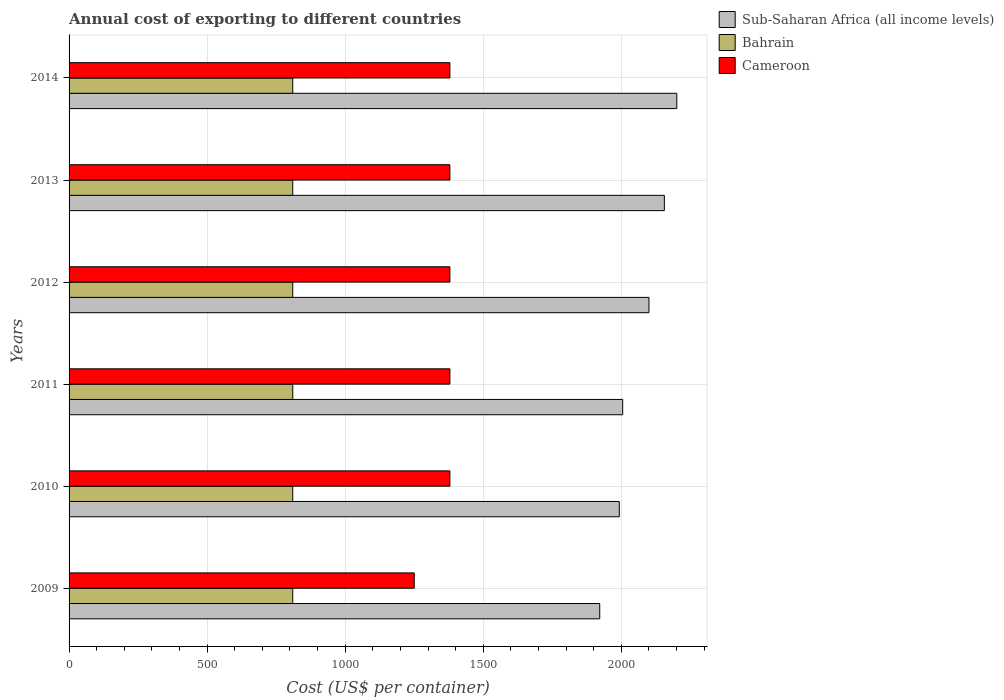How many different coloured bars are there?
Your answer should be very brief. 3. How many groups of bars are there?
Make the answer very short. 6. Are the number of bars per tick equal to the number of legend labels?
Keep it short and to the point. Yes. What is the total annual cost of exporting in Bahrain in 2010?
Offer a terse response. 810. Across all years, what is the maximum total annual cost of exporting in Bahrain?
Offer a terse response. 810. Across all years, what is the minimum total annual cost of exporting in Bahrain?
Provide a succinct answer. 810. In which year was the total annual cost of exporting in Bahrain minimum?
Offer a very short reply. 2009. What is the total total annual cost of exporting in Sub-Saharan Africa (all income levels) in the graph?
Keep it short and to the point. 1.24e+04. What is the difference between the total annual cost of exporting in Bahrain in 2009 and that in 2012?
Your answer should be very brief. 0. What is the difference between the total annual cost of exporting in Cameroon in 2011 and the total annual cost of exporting in Sub-Saharan Africa (all income levels) in 2013?
Offer a very short reply. -776.7. What is the average total annual cost of exporting in Bahrain per year?
Your response must be concise. 810. In the year 2009, what is the difference between the total annual cost of exporting in Sub-Saharan Africa (all income levels) and total annual cost of exporting in Cameroon?
Give a very brief answer. 671.63. What is the ratio of the total annual cost of exporting in Cameroon in 2009 to that in 2013?
Keep it short and to the point. 0.91. What is the difference between the highest and the second highest total annual cost of exporting in Bahrain?
Your answer should be very brief. 0. What is the difference between the highest and the lowest total annual cost of exporting in Cameroon?
Your answer should be compact. 129. In how many years, is the total annual cost of exporting in Cameroon greater than the average total annual cost of exporting in Cameroon taken over all years?
Ensure brevity in your answer.  5. What does the 2nd bar from the top in 2014 represents?
Provide a short and direct response. Bahrain. What does the 2nd bar from the bottom in 2010 represents?
Offer a very short reply. Bahrain. Is it the case that in every year, the sum of the total annual cost of exporting in Sub-Saharan Africa (all income levels) and total annual cost of exporting in Cameroon is greater than the total annual cost of exporting in Bahrain?
Give a very brief answer. Yes. How many bars are there?
Ensure brevity in your answer.  18. Are all the bars in the graph horizontal?
Provide a succinct answer. Yes. How many years are there in the graph?
Your response must be concise. 6. Are the values on the major ticks of X-axis written in scientific E-notation?
Offer a very short reply. No. Does the graph contain any zero values?
Your response must be concise. No. Where does the legend appear in the graph?
Your answer should be very brief. Top right. How are the legend labels stacked?
Offer a very short reply. Vertical. What is the title of the graph?
Give a very brief answer. Annual cost of exporting to different countries. Does "Congo (Democratic)" appear as one of the legend labels in the graph?
Your response must be concise. No. What is the label or title of the X-axis?
Keep it short and to the point. Cost (US$ per container). What is the Cost (US$ per container) in Sub-Saharan Africa (all income levels) in 2009?
Your answer should be compact. 1921.63. What is the Cost (US$ per container) in Bahrain in 2009?
Give a very brief answer. 810. What is the Cost (US$ per container) in Cameroon in 2009?
Your answer should be compact. 1250. What is the Cost (US$ per container) in Sub-Saharan Africa (all income levels) in 2010?
Make the answer very short. 1992.41. What is the Cost (US$ per container) of Bahrain in 2010?
Provide a succinct answer. 810. What is the Cost (US$ per container) of Cameroon in 2010?
Keep it short and to the point. 1379. What is the Cost (US$ per container) of Sub-Saharan Africa (all income levels) in 2011?
Keep it short and to the point. 2004.76. What is the Cost (US$ per container) of Bahrain in 2011?
Your answer should be very brief. 810. What is the Cost (US$ per container) of Cameroon in 2011?
Make the answer very short. 1379. What is the Cost (US$ per container) in Sub-Saharan Africa (all income levels) in 2012?
Provide a short and direct response. 2099.96. What is the Cost (US$ per container) of Bahrain in 2012?
Keep it short and to the point. 810. What is the Cost (US$ per container) of Cameroon in 2012?
Give a very brief answer. 1379. What is the Cost (US$ per container) of Sub-Saharan Africa (all income levels) in 2013?
Ensure brevity in your answer.  2155.7. What is the Cost (US$ per container) in Bahrain in 2013?
Your answer should be very brief. 810. What is the Cost (US$ per container) of Cameroon in 2013?
Offer a terse response. 1379. What is the Cost (US$ per container) in Sub-Saharan Africa (all income levels) in 2014?
Offer a very short reply. 2200.7. What is the Cost (US$ per container) of Bahrain in 2014?
Keep it short and to the point. 810. What is the Cost (US$ per container) of Cameroon in 2014?
Offer a terse response. 1379. Across all years, what is the maximum Cost (US$ per container) of Sub-Saharan Africa (all income levels)?
Offer a terse response. 2200.7. Across all years, what is the maximum Cost (US$ per container) in Bahrain?
Offer a terse response. 810. Across all years, what is the maximum Cost (US$ per container) of Cameroon?
Offer a very short reply. 1379. Across all years, what is the minimum Cost (US$ per container) of Sub-Saharan Africa (all income levels)?
Offer a terse response. 1921.63. Across all years, what is the minimum Cost (US$ per container) of Bahrain?
Provide a short and direct response. 810. Across all years, what is the minimum Cost (US$ per container) in Cameroon?
Your answer should be compact. 1250. What is the total Cost (US$ per container) in Sub-Saharan Africa (all income levels) in the graph?
Your answer should be very brief. 1.24e+04. What is the total Cost (US$ per container) of Bahrain in the graph?
Offer a very short reply. 4860. What is the total Cost (US$ per container) of Cameroon in the graph?
Offer a terse response. 8145. What is the difference between the Cost (US$ per container) of Sub-Saharan Africa (all income levels) in 2009 and that in 2010?
Provide a short and direct response. -70.78. What is the difference between the Cost (US$ per container) in Cameroon in 2009 and that in 2010?
Your answer should be very brief. -129. What is the difference between the Cost (US$ per container) in Sub-Saharan Africa (all income levels) in 2009 and that in 2011?
Offer a very short reply. -83.13. What is the difference between the Cost (US$ per container) in Bahrain in 2009 and that in 2011?
Provide a succinct answer. 0. What is the difference between the Cost (US$ per container) of Cameroon in 2009 and that in 2011?
Offer a very short reply. -129. What is the difference between the Cost (US$ per container) in Sub-Saharan Africa (all income levels) in 2009 and that in 2012?
Your answer should be compact. -178.33. What is the difference between the Cost (US$ per container) of Bahrain in 2009 and that in 2012?
Make the answer very short. 0. What is the difference between the Cost (US$ per container) of Cameroon in 2009 and that in 2012?
Provide a short and direct response. -129. What is the difference between the Cost (US$ per container) in Sub-Saharan Africa (all income levels) in 2009 and that in 2013?
Ensure brevity in your answer.  -234.07. What is the difference between the Cost (US$ per container) in Cameroon in 2009 and that in 2013?
Your response must be concise. -129. What is the difference between the Cost (US$ per container) in Sub-Saharan Africa (all income levels) in 2009 and that in 2014?
Your answer should be compact. -279.07. What is the difference between the Cost (US$ per container) of Cameroon in 2009 and that in 2014?
Give a very brief answer. -129. What is the difference between the Cost (US$ per container) in Sub-Saharan Africa (all income levels) in 2010 and that in 2011?
Provide a succinct answer. -12.35. What is the difference between the Cost (US$ per container) of Bahrain in 2010 and that in 2011?
Your answer should be very brief. 0. What is the difference between the Cost (US$ per container) in Sub-Saharan Africa (all income levels) in 2010 and that in 2012?
Your answer should be compact. -107.54. What is the difference between the Cost (US$ per container) in Sub-Saharan Africa (all income levels) in 2010 and that in 2013?
Make the answer very short. -163.29. What is the difference between the Cost (US$ per container) in Bahrain in 2010 and that in 2013?
Provide a short and direct response. 0. What is the difference between the Cost (US$ per container) in Sub-Saharan Africa (all income levels) in 2010 and that in 2014?
Make the answer very short. -208.29. What is the difference between the Cost (US$ per container) of Cameroon in 2010 and that in 2014?
Offer a terse response. 0. What is the difference between the Cost (US$ per container) of Sub-Saharan Africa (all income levels) in 2011 and that in 2012?
Make the answer very short. -95.2. What is the difference between the Cost (US$ per container) in Sub-Saharan Africa (all income levels) in 2011 and that in 2013?
Your response must be concise. -150.94. What is the difference between the Cost (US$ per container) of Bahrain in 2011 and that in 2013?
Provide a succinct answer. 0. What is the difference between the Cost (US$ per container) in Cameroon in 2011 and that in 2013?
Give a very brief answer. 0. What is the difference between the Cost (US$ per container) of Sub-Saharan Africa (all income levels) in 2011 and that in 2014?
Your answer should be very brief. -195.94. What is the difference between the Cost (US$ per container) of Sub-Saharan Africa (all income levels) in 2012 and that in 2013?
Provide a short and direct response. -55.74. What is the difference between the Cost (US$ per container) of Sub-Saharan Africa (all income levels) in 2012 and that in 2014?
Offer a terse response. -100.74. What is the difference between the Cost (US$ per container) of Sub-Saharan Africa (all income levels) in 2013 and that in 2014?
Provide a succinct answer. -45. What is the difference between the Cost (US$ per container) in Bahrain in 2013 and that in 2014?
Provide a succinct answer. 0. What is the difference between the Cost (US$ per container) of Sub-Saharan Africa (all income levels) in 2009 and the Cost (US$ per container) of Bahrain in 2010?
Your answer should be very brief. 1111.63. What is the difference between the Cost (US$ per container) of Sub-Saharan Africa (all income levels) in 2009 and the Cost (US$ per container) of Cameroon in 2010?
Give a very brief answer. 542.63. What is the difference between the Cost (US$ per container) in Bahrain in 2009 and the Cost (US$ per container) in Cameroon in 2010?
Provide a short and direct response. -569. What is the difference between the Cost (US$ per container) of Sub-Saharan Africa (all income levels) in 2009 and the Cost (US$ per container) of Bahrain in 2011?
Give a very brief answer. 1111.63. What is the difference between the Cost (US$ per container) in Sub-Saharan Africa (all income levels) in 2009 and the Cost (US$ per container) in Cameroon in 2011?
Your answer should be very brief. 542.63. What is the difference between the Cost (US$ per container) in Bahrain in 2009 and the Cost (US$ per container) in Cameroon in 2011?
Your answer should be very brief. -569. What is the difference between the Cost (US$ per container) in Sub-Saharan Africa (all income levels) in 2009 and the Cost (US$ per container) in Bahrain in 2012?
Keep it short and to the point. 1111.63. What is the difference between the Cost (US$ per container) of Sub-Saharan Africa (all income levels) in 2009 and the Cost (US$ per container) of Cameroon in 2012?
Your response must be concise. 542.63. What is the difference between the Cost (US$ per container) in Bahrain in 2009 and the Cost (US$ per container) in Cameroon in 2012?
Make the answer very short. -569. What is the difference between the Cost (US$ per container) of Sub-Saharan Africa (all income levels) in 2009 and the Cost (US$ per container) of Bahrain in 2013?
Give a very brief answer. 1111.63. What is the difference between the Cost (US$ per container) of Sub-Saharan Africa (all income levels) in 2009 and the Cost (US$ per container) of Cameroon in 2013?
Your response must be concise. 542.63. What is the difference between the Cost (US$ per container) in Bahrain in 2009 and the Cost (US$ per container) in Cameroon in 2013?
Your answer should be compact. -569. What is the difference between the Cost (US$ per container) in Sub-Saharan Africa (all income levels) in 2009 and the Cost (US$ per container) in Bahrain in 2014?
Make the answer very short. 1111.63. What is the difference between the Cost (US$ per container) in Sub-Saharan Africa (all income levels) in 2009 and the Cost (US$ per container) in Cameroon in 2014?
Provide a short and direct response. 542.63. What is the difference between the Cost (US$ per container) in Bahrain in 2009 and the Cost (US$ per container) in Cameroon in 2014?
Your response must be concise. -569. What is the difference between the Cost (US$ per container) of Sub-Saharan Africa (all income levels) in 2010 and the Cost (US$ per container) of Bahrain in 2011?
Your response must be concise. 1182.41. What is the difference between the Cost (US$ per container) in Sub-Saharan Africa (all income levels) in 2010 and the Cost (US$ per container) in Cameroon in 2011?
Provide a succinct answer. 613.41. What is the difference between the Cost (US$ per container) in Bahrain in 2010 and the Cost (US$ per container) in Cameroon in 2011?
Your answer should be compact. -569. What is the difference between the Cost (US$ per container) of Sub-Saharan Africa (all income levels) in 2010 and the Cost (US$ per container) of Bahrain in 2012?
Your answer should be compact. 1182.41. What is the difference between the Cost (US$ per container) of Sub-Saharan Africa (all income levels) in 2010 and the Cost (US$ per container) of Cameroon in 2012?
Your answer should be very brief. 613.41. What is the difference between the Cost (US$ per container) of Bahrain in 2010 and the Cost (US$ per container) of Cameroon in 2012?
Make the answer very short. -569. What is the difference between the Cost (US$ per container) in Sub-Saharan Africa (all income levels) in 2010 and the Cost (US$ per container) in Bahrain in 2013?
Offer a terse response. 1182.41. What is the difference between the Cost (US$ per container) of Sub-Saharan Africa (all income levels) in 2010 and the Cost (US$ per container) of Cameroon in 2013?
Keep it short and to the point. 613.41. What is the difference between the Cost (US$ per container) of Bahrain in 2010 and the Cost (US$ per container) of Cameroon in 2013?
Make the answer very short. -569. What is the difference between the Cost (US$ per container) of Sub-Saharan Africa (all income levels) in 2010 and the Cost (US$ per container) of Bahrain in 2014?
Make the answer very short. 1182.41. What is the difference between the Cost (US$ per container) in Sub-Saharan Africa (all income levels) in 2010 and the Cost (US$ per container) in Cameroon in 2014?
Provide a succinct answer. 613.41. What is the difference between the Cost (US$ per container) of Bahrain in 2010 and the Cost (US$ per container) of Cameroon in 2014?
Provide a succinct answer. -569. What is the difference between the Cost (US$ per container) in Sub-Saharan Africa (all income levels) in 2011 and the Cost (US$ per container) in Bahrain in 2012?
Provide a succinct answer. 1194.76. What is the difference between the Cost (US$ per container) in Sub-Saharan Africa (all income levels) in 2011 and the Cost (US$ per container) in Cameroon in 2012?
Your answer should be compact. 625.76. What is the difference between the Cost (US$ per container) in Bahrain in 2011 and the Cost (US$ per container) in Cameroon in 2012?
Offer a very short reply. -569. What is the difference between the Cost (US$ per container) in Sub-Saharan Africa (all income levels) in 2011 and the Cost (US$ per container) in Bahrain in 2013?
Ensure brevity in your answer.  1194.76. What is the difference between the Cost (US$ per container) in Sub-Saharan Africa (all income levels) in 2011 and the Cost (US$ per container) in Cameroon in 2013?
Provide a succinct answer. 625.76. What is the difference between the Cost (US$ per container) in Bahrain in 2011 and the Cost (US$ per container) in Cameroon in 2013?
Keep it short and to the point. -569. What is the difference between the Cost (US$ per container) in Sub-Saharan Africa (all income levels) in 2011 and the Cost (US$ per container) in Bahrain in 2014?
Provide a short and direct response. 1194.76. What is the difference between the Cost (US$ per container) in Sub-Saharan Africa (all income levels) in 2011 and the Cost (US$ per container) in Cameroon in 2014?
Make the answer very short. 625.76. What is the difference between the Cost (US$ per container) in Bahrain in 2011 and the Cost (US$ per container) in Cameroon in 2014?
Your response must be concise. -569. What is the difference between the Cost (US$ per container) in Sub-Saharan Africa (all income levels) in 2012 and the Cost (US$ per container) in Bahrain in 2013?
Provide a succinct answer. 1289.96. What is the difference between the Cost (US$ per container) of Sub-Saharan Africa (all income levels) in 2012 and the Cost (US$ per container) of Cameroon in 2013?
Ensure brevity in your answer.  720.96. What is the difference between the Cost (US$ per container) in Bahrain in 2012 and the Cost (US$ per container) in Cameroon in 2013?
Keep it short and to the point. -569. What is the difference between the Cost (US$ per container) in Sub-Saharan Africa (all income levels) in 2012 and the Cost (US$ per container) in Bahrain in 2014?
Provide a short and direct response. 1289.96. What is the difference between the Cost (US$ per container) in Sub-Saharan Africa (all income levels) in 2012 and the Cost (US$ per container) in Cameroon in 2014?
Make the answer very short. 720.96. What is the difference between the Cost (US$ per container) in Bahrain in 2012 and the Cost (US$ per container) in Cameroon in 2014?
Make the answer very short. -569. What is the difference between the Cost (US$ per container) of Sub-Saharan Africa (all income levels) in 2013 and the Cost (US$ per container) of Bahrain in 2014?
Your answer should be very brief. 1345.7. What is the difference between the Cost (US$ per container) of Sub-Saharan Africa (all income levels) in 2013 and the Cost (US$ per container) of Cameroon in 2014?
Provide a short and direct response. 776.7. What is the difference between the Cost (US$ per container) in Bahrain in 2013 and the Cost (US$ per container) in Cameroon in 2014?
Provide a short and direct response. -569. What is the average Cost (US$ per container) of Sub-Saharan Africa (all income levels) per year?
Provide a succinct answer. 2062.53. What is the average Cost (US$ per container) of Bahrain per year?
Your response must be concise. 810. What is the average Cost (US$ per container) in Cameroon per year?
Your response must be concise. 1357.5. In the year 2009, what is the difference between the Cost (US$ per container) in Sub-Saharan Africa (all income levels) and Cost (US$ per container) in Bahrain?
Provide a short and direct response. 1111.63. In the year 2009, what is the difference between the Cost (US$ per container) in Sub-Saharan Africa (all income levels) and Cost (US$ per container) in Cameroon?
Ensure brevity in your answer.  671.63. In the year 2009, what is the difference between the Cost (US$ per container) in Bahrain and Cost (US$ per container) in Cameroon?
Offer a very short reply. -440. In the year 2010, what is the difference between the Cost (US$ per container) of Sub-Saharan Africa (all income levels) and Cost (US$ per container) of Bahrain?
Give a very brief answer. 1182.41. In the year 2010, what is the difference between the Cost (US$ per container) of Sub-Saharan Africa (all income levels) and Cost (US$ per container) of Cameroon?
Keep it short and to the point. 613.41. In the year 2010, what is the difference between the Cost (US$ per container) of Bahrain and Cost (US$ per container) of Cameroon?
Offer a very short reply. -569. In the year 2011, what is the difference between the Cost (US$ per container) in Sub-Saharan Africa (all income levels) and Cost (US$ per container) in Bahrain?
Make the answer very short. 1194.76. In the year 2011, what is the difference between the Cost (US$ per container) of Sub-Saharan Africa (all income levels) and Cost (US$ per container) of Cameroon?
Your answer should be very brief. 625.76. In the year 2011, what is the difference between the Cost (US$ per container) in Bahrain and Cost (US$ per container) in Cameroon?
Give a very brief answer. -569. In the year 2012, what is the difference between the Cost (US$ per container) of Sub-Saharan Africa (all income levels) and Cost (US$ per container) of Bahrain?
Offer a terse response. 1289.96. In the year 2012, what is the difference between the Cost (US$ per container) of Sub-Saharan Africa (all income levels) and Cost (US$ per container) of Cameroon?
Make the answer very short. 720.96. In the year 2012, what is the difference between the Cost (US$ per container) of Bahrain and Cost (US$ per container) of Cameroon?
Offer a very short reply. -569. In the year 2013, what is the difference between the Cost (US$ per container) of Sub-Saharan Africa (all income levels) and Cost (US$ per container) of Bahrain?
Provide a short and direct response. 1345.7. In the year 2013, what is the difference between the Cost (US$ per container) in Sub-Saharan Africa (all income levels) and Cost (US$ per container) in Cameroon?
Keep it short and to the point. 776.7. In the year 2013, what is the difference between the Cost (US$ per container) of Bahrain and Cost (US$ per container) of Cameroon?
Ensure brevity in your answer.  -569. In the year 2014, what is the difference between the Cost (US$ per container) in Sub-Saharan Africa (all income levels) and Cost (US$ per container) in Bahrain?
Provide a short and direct response. 1390.7. In the year 2014, what is the difference between the Cost (US$ per container) of Sub-Saharan Africa (all income levels) and Cost (US$ per container) of Cameroon?
Offer a terse response. 821.7. In the year 2014, what is the difference between the Cost (US$ per container) in Bahrain and Cost (US$ per container) in Cameroon?
Make the answer very short. -569. What is the ratio of the Cost (US$ per container) of Sub-Saharan Africa (all income levels) in 2009 to that in 2010?
Keep it short and to the point. 0.96. What is the ratio of the Cost (US$ per container) in Bahrain in 2009 to that in 2010?
Give a very brief answer. 1. What is the ratio of the Cost (US$ per container) of Cameroon in 2009 to that in 2010?
Keep it short and to the point. 0.91. What is the ratio of the Cost (US$ per container) of Sub-Saharan Africa (all income levels) in 2009 to that in 2011?
Provide a short and direct response. 0.96. What is the ratio of the Cost (US$ per container) in Bahrain in 2009 to that in 2011?
Your answer should be compact. 1. What is the ratio of the Cost (US$ per container) of Cameroon in 2009 to that in 2011?
Give a very brief answer. 0.91. What is the ratio of the Cost (US$ per container) in Sub-Saharan Africa (all income levels) in 2009 to that in 2012?
Your response must be concise. 0.92. What is the ratio of the Cost (US$ per container) in Bahrain in 2009 to that in 2012?
Your answer should be compact. 1. What is the ratio of the Cost (US$ per container) in Cameroon in 2009 to that in 2012?
Your answer should be compact. 0.91. What is the ratio of the Cost (US$ per container) in Sub-Saharan Africa (all income levels) in 2009 to that in 2013?
Your answer should be very brief. 0.89. What is the ratio of the Cost (US$ per container) of Bahrain in 2009 to that in 2013?
Provide a short and direct response. 1. What is the ratio of the Cost (US$ per container) of Cameroon in 2009 to that in 2013?
Your answer should be compact. 0.91. What is the ratio of the Cost (US$ per container) in Sub-Saharan Africa (all income levels) in 2009 to that in 2014?
Your response must be concise. 0.87. What is the ratio of the Cost (US$ per container) in Cameroon in 2009 to that in 2014?
Keep it short and to the point. 0.91. What is the ratio of the Cost (US$ per container) in Sub-Saharan Africa (all income levels) in 2010 to that in 2011?
Provide a short and direct response. 0.99. What is the ratio of the Cost (US$ per container) of Sub-Saharan Africa (all income levels) in 2010 to that in 2012?
Ensure brevity in your answer.  0.95. What is the ratio of the Cost (US$ per container) of Cameroon in 2010 to that in 2012?
Your answer should be very brief. 1. What is the ratio of the Cost (US$ per container) in Sub-Saharan Africa (all income levels) in 2010 to that in 2013?
Give a very brief answer. 0.92. What is the ratio of the Cost (US$ per container) in Bahrain in 2010 to that in 2013?
Keep it short and to the point. 1. What is the ratio of the Cost (US$ per container) in Cameroon in 2010 to that in 2013?
Your answer should be compact. 1. What is the ratio of the Cost (US$ per container) in Sub-Saharan Africa (all income levels) in 2010 to that in 2014?
Keep it short and to the point. 0.91. What is the ratio of the Cost (US$ per container) in Bahrain in 2010 to that in 2014?
Provide a short and direct response. 1. What is the ratio of the Cost (US$ per container) in Sub-Saharan Africa (all income levels) in 2011 to that in 2012?
Ensure brevity in your answer.  0.95. What is the ratio of the Cost (US$ per container) of Bahrain in 2011 to that in 2013?
Keep it short and to the point. 1. What is the ratio of the Cost (US$ per container) in Cameroon in 2011 to that in 2013?
Your answer should be very brief. 1. What is the ratio of the Cost (US$ per container) of Sub-Saharan Africa (all income levels) in 2011 to that in 2014?
Your answer should be compact. 0.91. What is the ratio of the Cost (US$ per container) of Bahrain in 2011 to that in 2014?
Give a very brief answer. 1. What is the ratio of the Cost (US$ per container) of Cameroon in 2011 to that in 2014?
Provide a succinct answer. 1. What is the ratio of the Cost (US$ per container) in Sub-Saharan Africa (all income levels) in 2012 to that in 2013?
Offer a very short reply. 0.97. What is the ratio of the Cost (US$ per container) in Bahrain in 2012 to that in 2013?
Your answer should be very brief. 1. What is the ratio of the Cost (US$ per container) of Sub-Saharan Africa (all income levels) in 2012 to that in 2014?
Your answer should be very brief. 0.95. What is the ratio of the Cost (US$ per container) in Bahrain in 2012 to that in 2014?
Your answer should be very brief. 1. What is the ratio of the Cost (US$ per container) in Sub-Saharan Africa (all income levels) in 2013 to that in 2014?
Your answer should be compact. 0.98. What is the ratio of the Cost (US$ per container) of Cameroon in 2013 to that in 2014?
Your answer should be very brief. 1. What is the difference between the highest and the second highest Cost (US$ per container) in Bahrain?
Provide a succinct answer. 0. What is the difference between the highest and the second highest Cost (US$ per container) in Cameroon?
Provide a short and direct response. 0. What is the difference between the highest and the lowest Cost (US$ per container) in Sub-Saharan Africa (all income levels)?
Offer a terse response. 279.07. What is the difference between the highest and the lowest Cost (US$ per container) in Cameroon?
Offer a terse response. 129. 